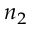<formula> <loc_0><loc_0><loc_500><loc_500>n _ { 2 }</formula> 